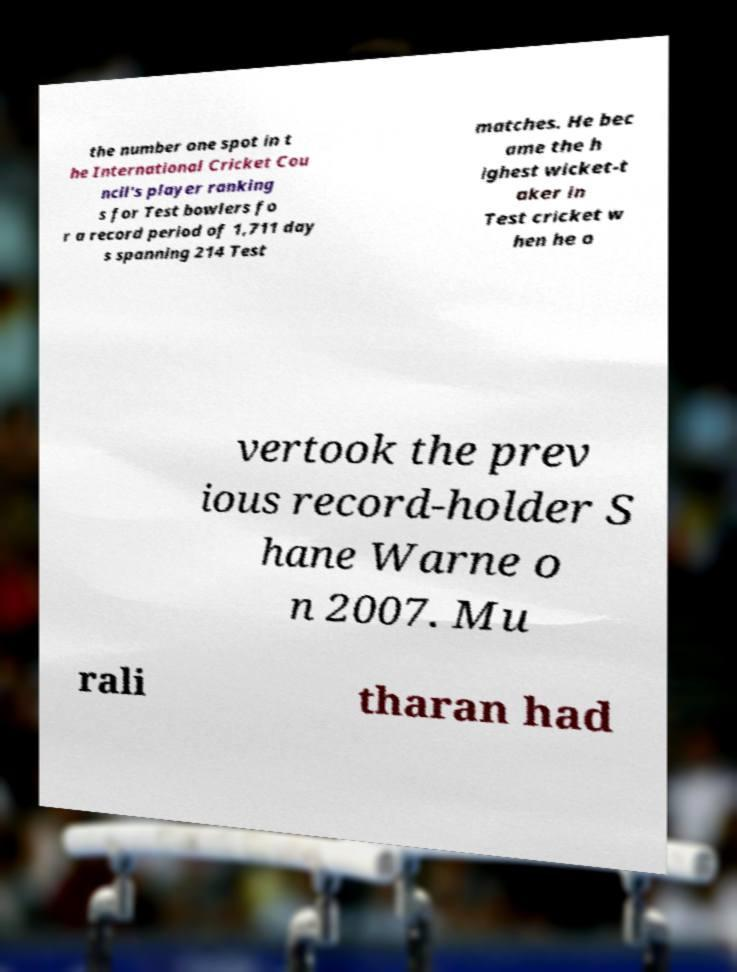Can you accurately transcribe the text from the provided image for me? the number one spot in t he International Cricket Cou ncil's player ranking s for Test bowlers fo r a record period of 1,711 day s spanning 214 Test matches. He bec ame the h ighest wicket-t aker in Test cricket w hen he o vertook the prev ious record-holder S hane Warne o n 2007. Mu rali tharan had 